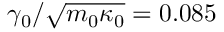<formula> <loc_0><loc_0><loc_500><loc_500>\gamma _ { 0 } / \sqrt { m _ { 0 } \kappa _ { 0 } } = 0 . 0 8 5</formula> 